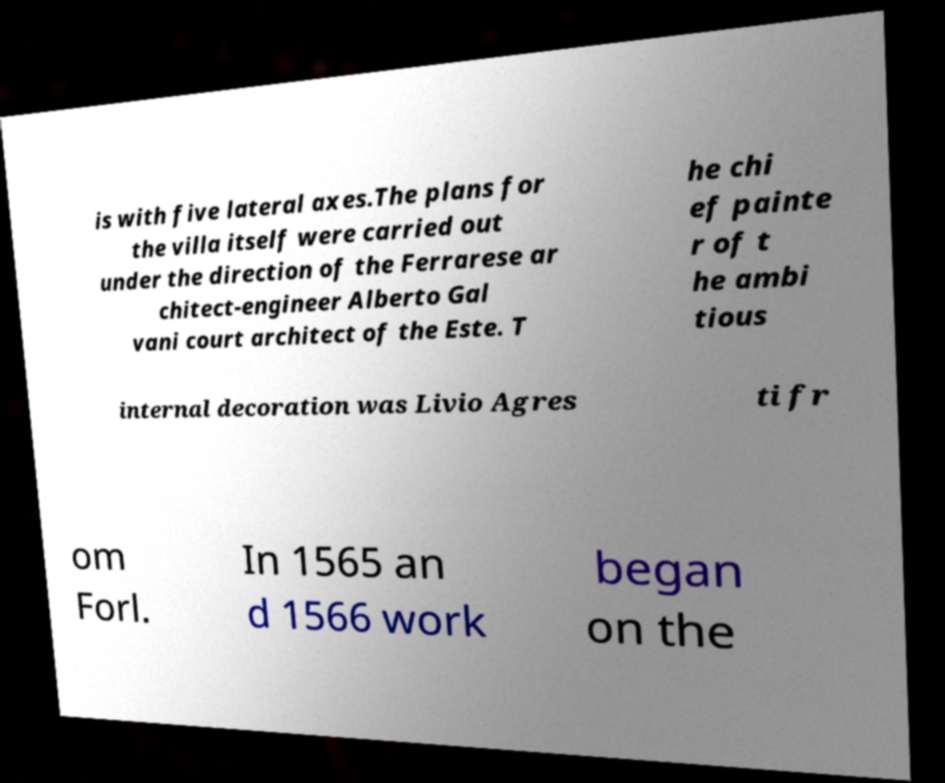For documentation purposes, I need the text within this image transcribed. Could you provide that? is with five lateral axes.The plans for the villa itself were carried out under the direction of the Ferrarese ar chitect-engineer Alberto Gal vani court architect of the Este. T he chi ef painte r of t he ambi tious internal decoration was Livio Agres ti fr om Forl. In 1565 an d 1566 work began on the 